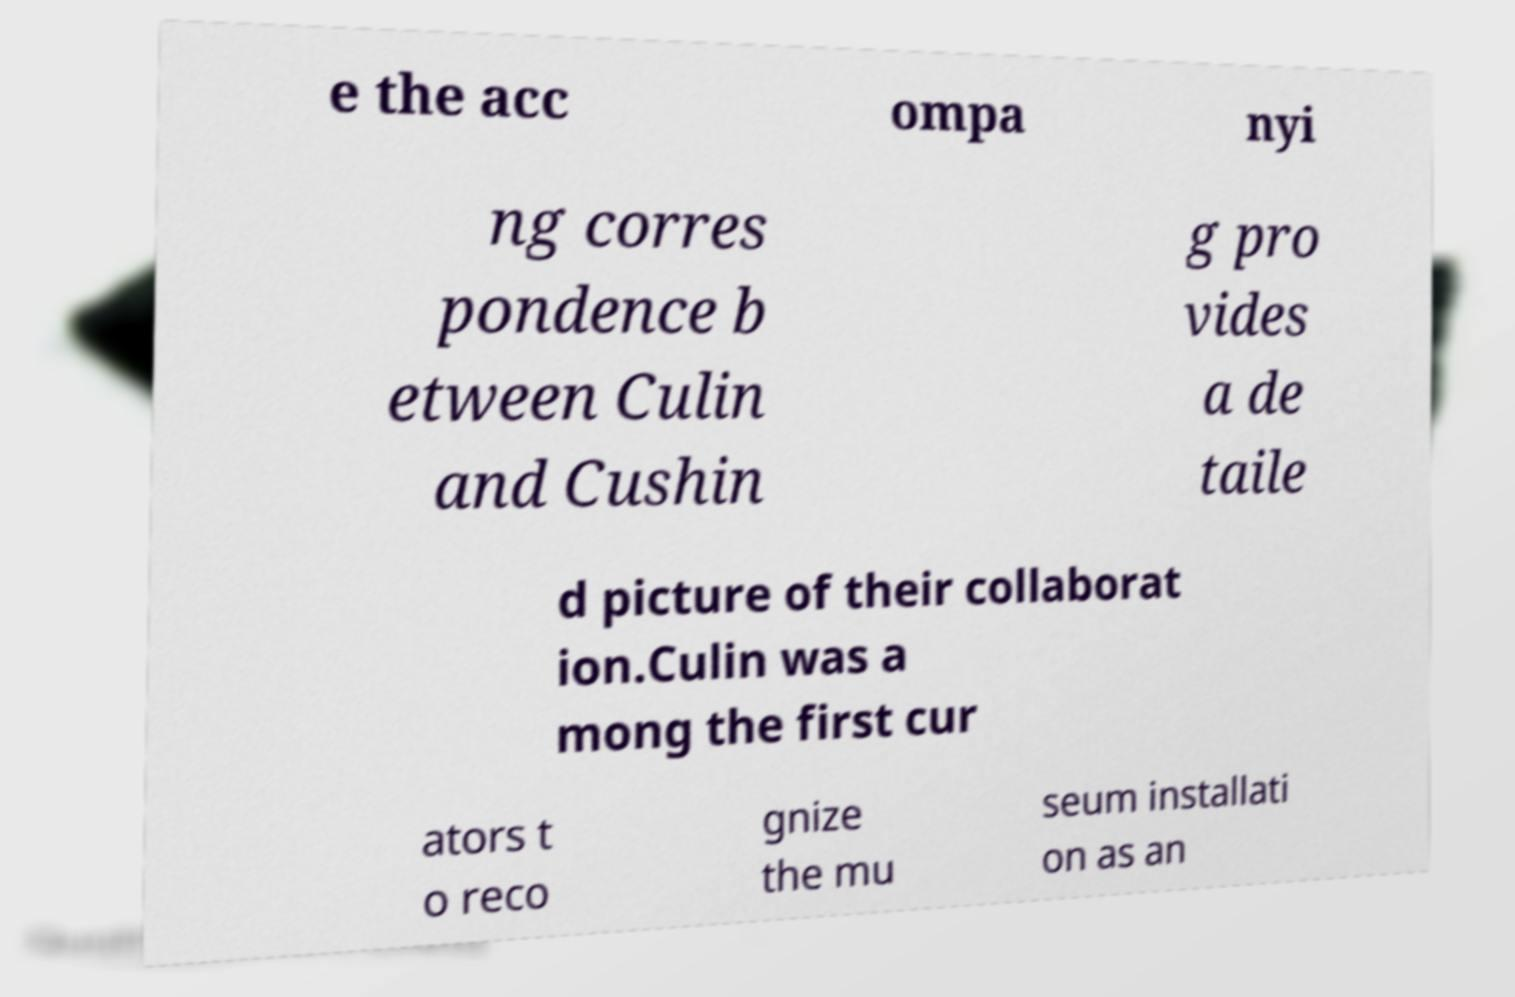Can you read and provide the text displayed in the image?This photo seems to have some interesting text. Can you extract and type it out for me? e the acc ompa nyi ng corres pondence b etween Culin and Cushin g pro vides a de taile d picture of their collaborat ion.Culin was a mong the first cur ators t o reco gnize the mu seum installati on as an 